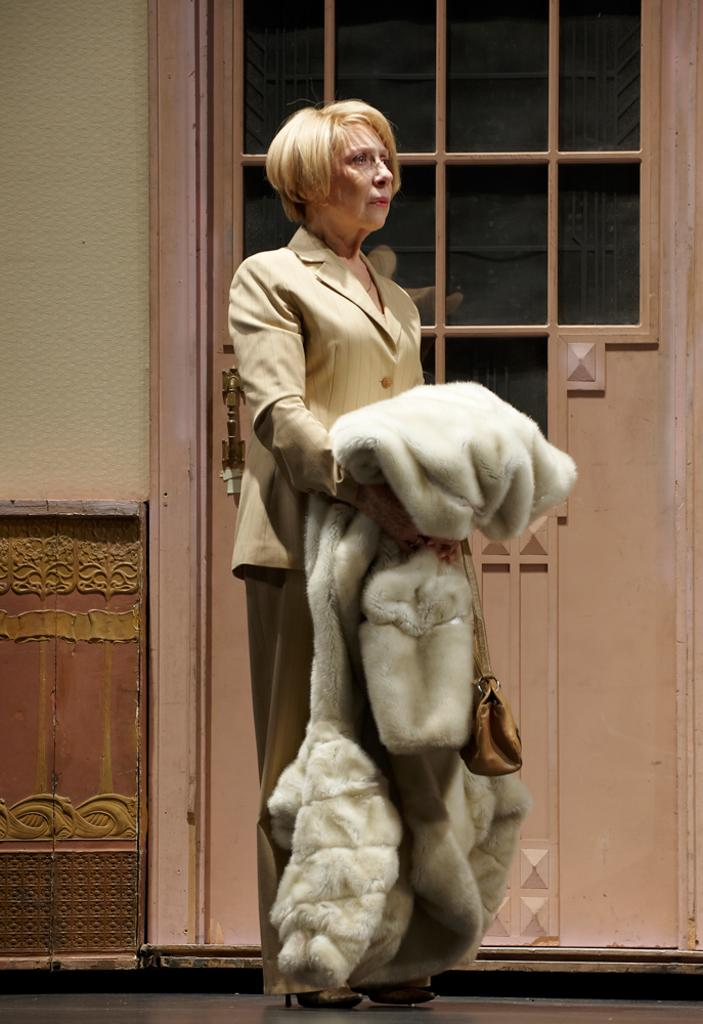Who is present in the image? There is a woman in the image. What is the woman doing in the image? The woman is standing in the image. What is the woman holding in her hand? The woman is holding a blanket in her hand. What can be seen in the background of the image? There is a closed door and a wall in the background of the image. What type of reward can be seen hanging on the wall in the image? There is no reward visible on the wall in the image; only a closed door and a wall are present. 